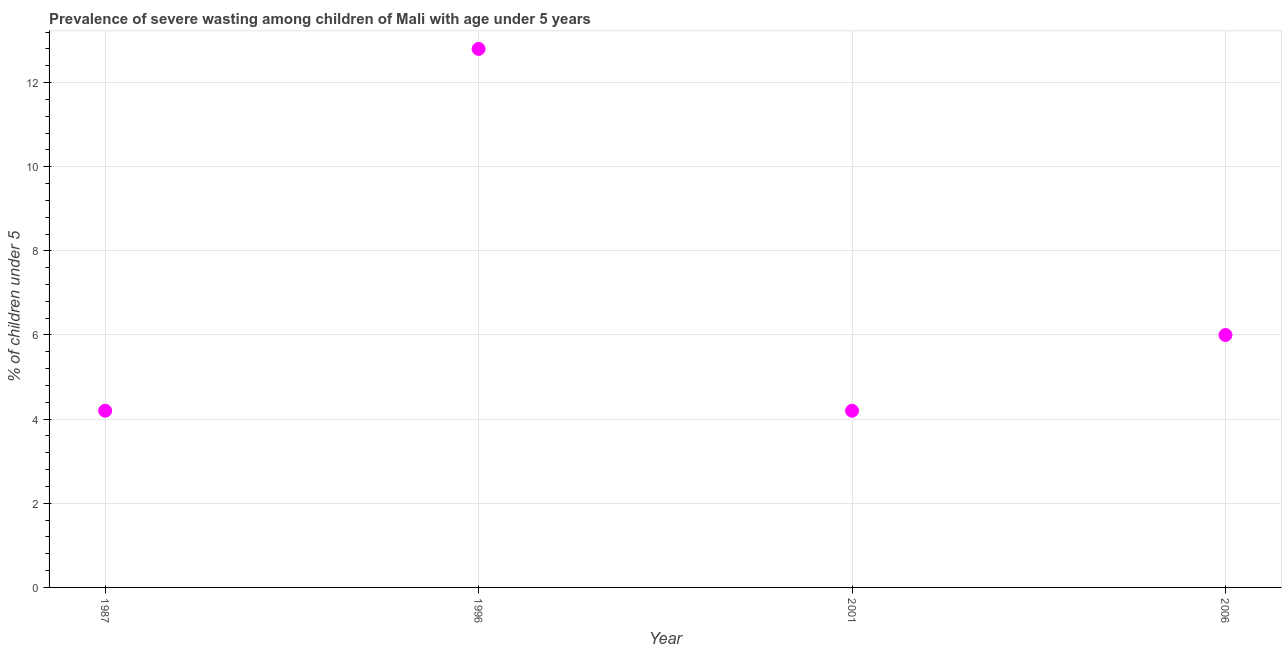What is the prevalence of severe wasting in 2001?
Make the answer very short. 4.2. Across all years, what is the maximum prevalence of severe wasting?
Keep it short and to the point. 12.8. Across all years, what is the minimum prevalence of severe wasting?
Provide a succinct answer. 4.2. What is the sum of the prevalence of severe wasting?
Provide a succinct answer. 27.2. What is the average prevalence of severe wasting per year?
Your answer should be compact. 6.8. What is the median prevalence of severe wasting?
Your answer should be compact. 5.1. In how many years, is the prevalence of severe wasting greater than 9.2 %?
Make the answer very short. 1. Do a majority of the years between 1987 and 2006 (inclusive) have prevalence of severe wasting greater than 7.6 %?
Provide a short and direct response. No. Is the prevalence of severe wasting in 1996 less than that in 2006?
Your response must be concise. No. Is the difference between the prevalence of severe wasting in 1987 and 2001 greater than the difference between any two years?
Your response must be concise. No. What is the difference between the highest and the second highest prevalence of severe wasting?
Give a very brief answer. 6.8. Is the sum of the prevalence of severe wasting in 1996 and 2001 greater than the maximum prevalence of severe wasting across all years?
Your answer should be very brief. Yes. What is the difference between the highest and the lowest prevalence of severe wasting?
Your response must be concise. 8.6. Are the values on the major ticks of Y-axis written in scientific E-notation?
Give a very brief answer. No. What is the title of the graph?
Provide a succinct answer. Prevalence of severe wasting among children of Mali with age under 5 years. What is the label or title of the Y-axis?
Offer a very short reply.  % of children under 5. What is the  % of children under 5 in 1987?
Offer a terse response. 4.2. What is the  % of children under 5 in 1996?
Offer a terse response. 12.8. What is the  % of children under 5 in 2001?
Make the answer very short. 4.2. What is the  % of children under 5 in 2006?
Your response must be concise. 6. What is the difference between the  % of children under 5 in 1987 and 1996?
Offer a terse response. -8.6. What is the difference between the  % of children under 5 in 1987 and 2001?
Ensure brevity in your answer.  0. What is the difference between the  % of children under 5 in 1987 and 2006?
Make the answer very short. -1.8. What is the ratio of the  % of children under 5 in 1987 to that in 1996?
Your response must be concise. 0.33. What is the ratio of the  % of children under 5 in 1987 to that in 2001?
Offer a terse response. 1. What is the ratio of the  % of children under 5 in 1987 to that in 2006?
Your answer should be compact. 0.7. What is the ratio of the  % of children under 5 in 1996 to that in 2001?
Your answer should be compact. 3.05. What is the ratio of the  % of children under 5 in 1996 to that in 2006?
Offer a very short reply. 2.13. 